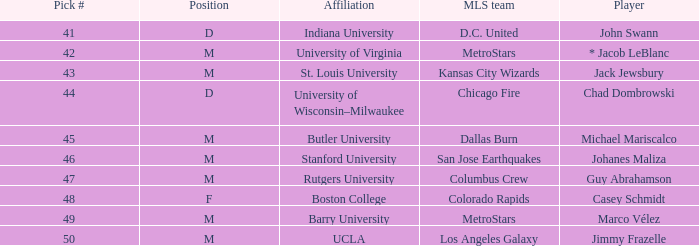What is the position of the Colorado Rapids team? F. 